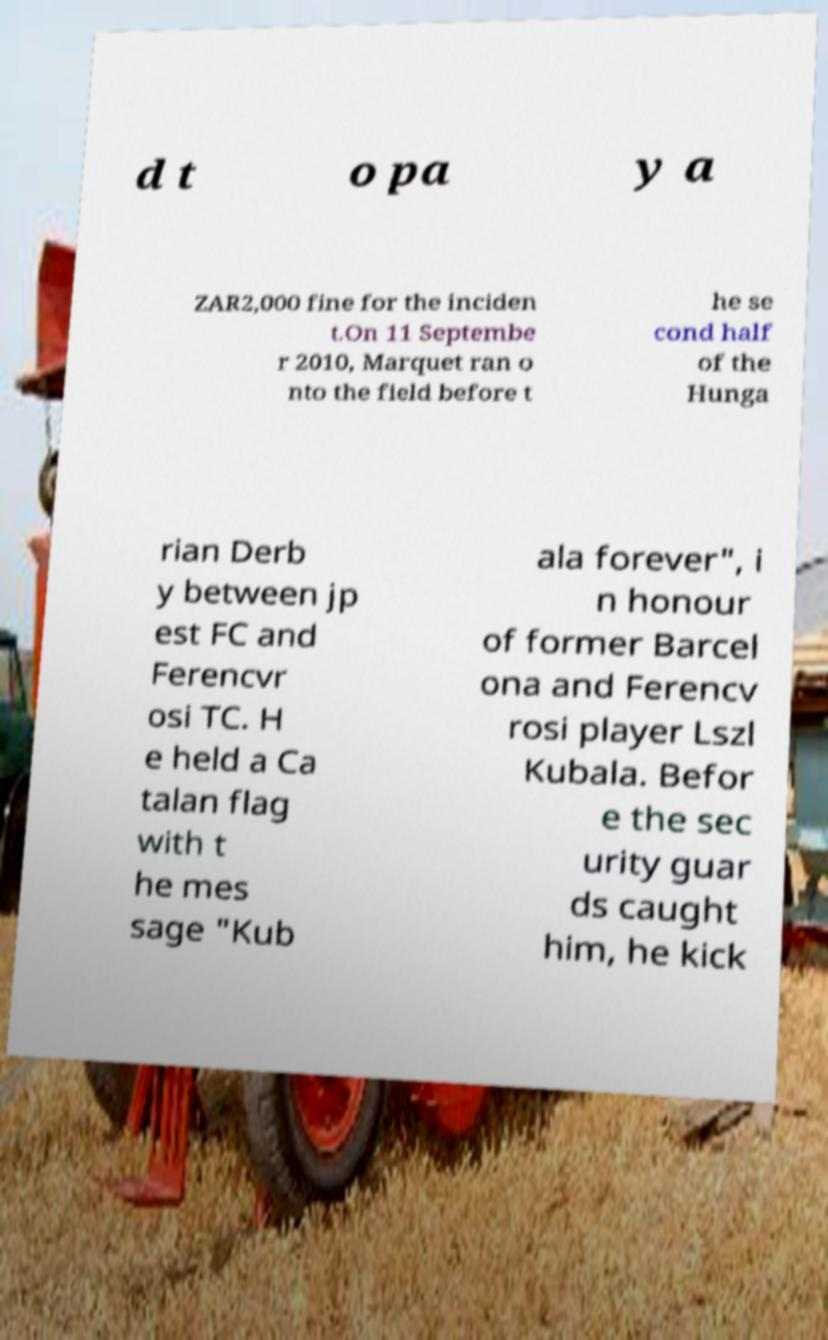I need the written content from this picture converted into text. Can you do that? d t o pa y a ZAR2,000 fine for the inciden t.On 11 Septembe r 2010, Marquet ran o nto the field before t he se cond half of the Hunga rian Derb y between jp est FC and Ferencvr osi TC. H e held a Ca talan flag with t he mes sage "Kub ala forever", i n honour of former Barcel ona and Ferencv rosi player Lszl Kubala. Befor e the sec urity guar ds caught him, he kick 